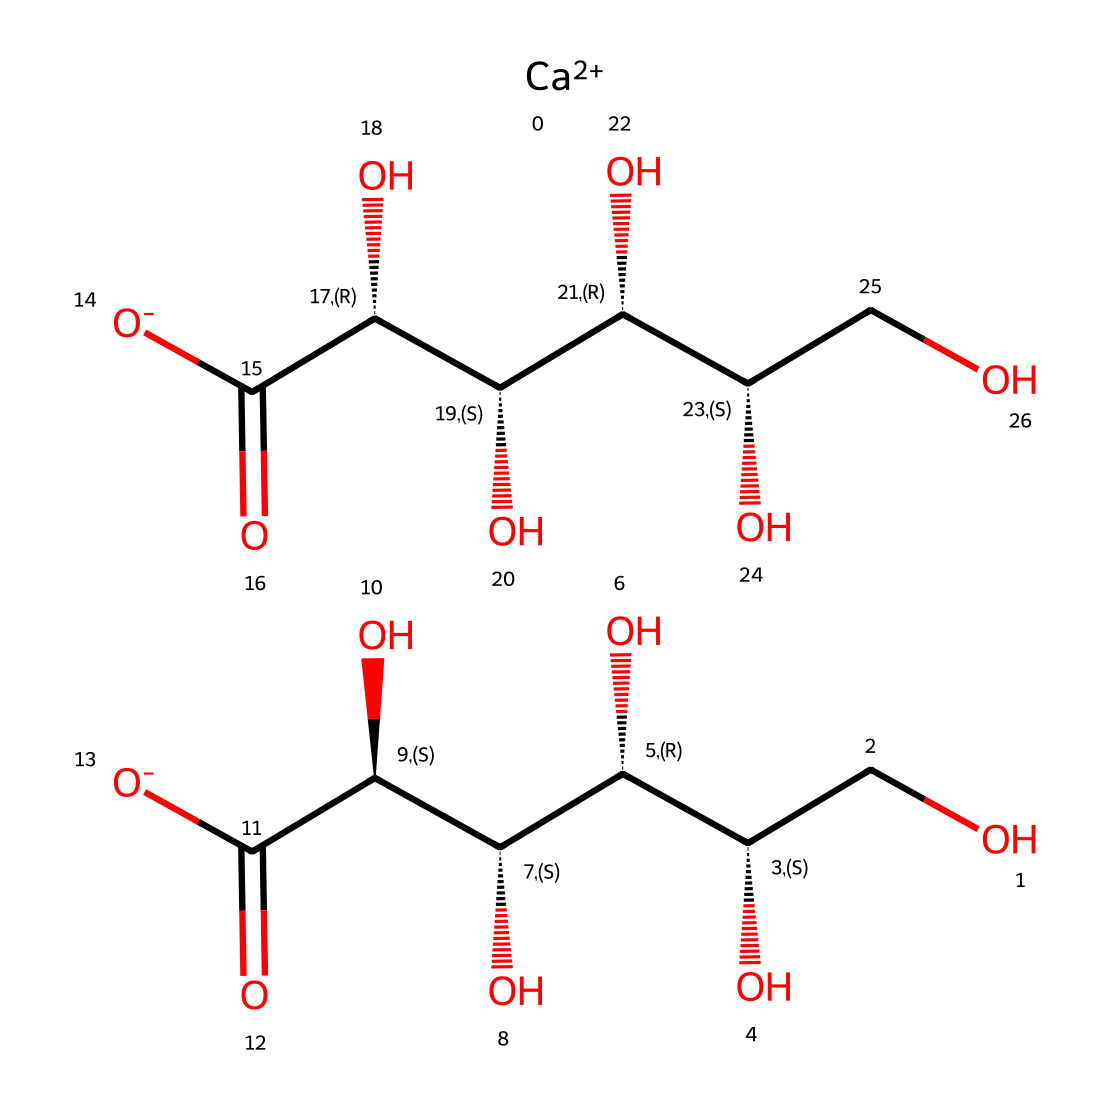What is the main cation in this chemical? The chemical structure contains a calcium ion represented by [Ca++], indicating that calcium is the main cation.
Answer: calcium How many hydroxyl (–OH) groups are present in the molecule? There are six –OH groups, as indicated by the six occurrences of the letter 'O' in the structure that are connected to carbon atoms without the presence of a carbonyl group nearby.
Answer: six What is the role of calcium gluconate in beverages? Calcium gluconate acts as a fortifying agent, which means it is used to add calcium to fortified beverages for nutritional enhancement.
Answer: fortifying agent How many carboxylate (–COO−) groups are present in this chemical? The structure shows two carboxylate groups, indicated by the presence of [C(=O)[O-]] present twice in the molecule.
Answer: two What type of bonding is present between the calcium ion and the gluconate? The bond connecting the calcium ion to the gluconate is primarily ionic bonding due to the electrostatic attraction between the positively charged calcium and the negatively charged carboxylate group.
Answer: ionic bonding Which part of the molecule contributes to its electrolyte properties? The presence of the free calcium ion ([Ca++]) and the dissociated carboxylate groups ([O−]), which can dissociate in solution, contributes to its electrolyte properties.
Answer: calcium ion and carboxylate groups How many stereocenters are present in the glucopyranose part of the molecule? The glucopyranose part contains four stereocenters based on the chiral carbons present in the structure, which can be identified by looking at the chiral centers where four different groups are attached.
Answer: four 